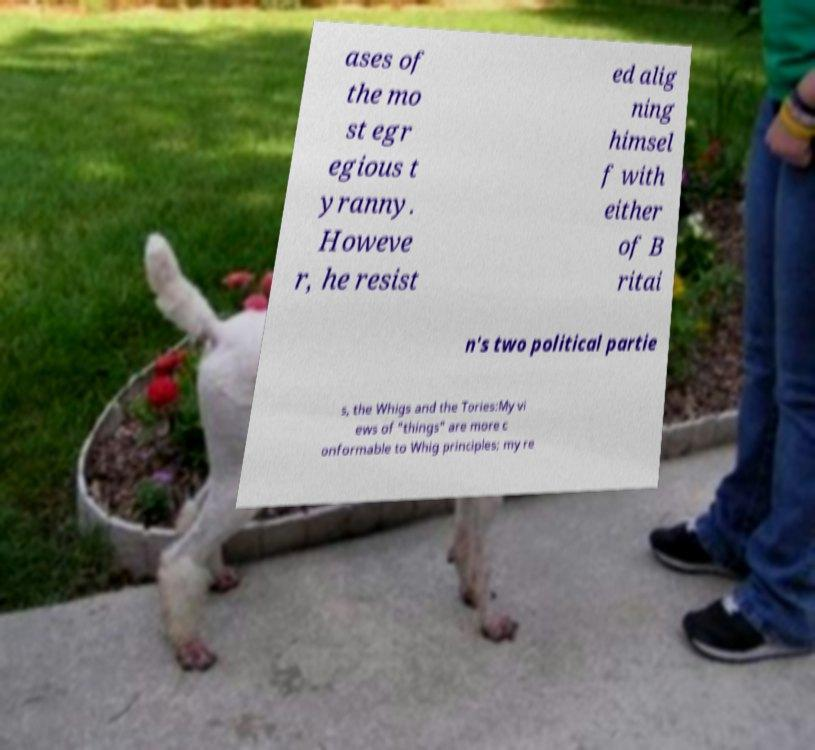Please identify and transcribe the text found in this image. ases of the mo st egr egious t yranny. Howeve r, he resist ed alig ning himsel f with either of B ritai n's two political partie s, the Whigs and the Tories:My vi ews of "things" are more c onformable to Whig principles; my re 